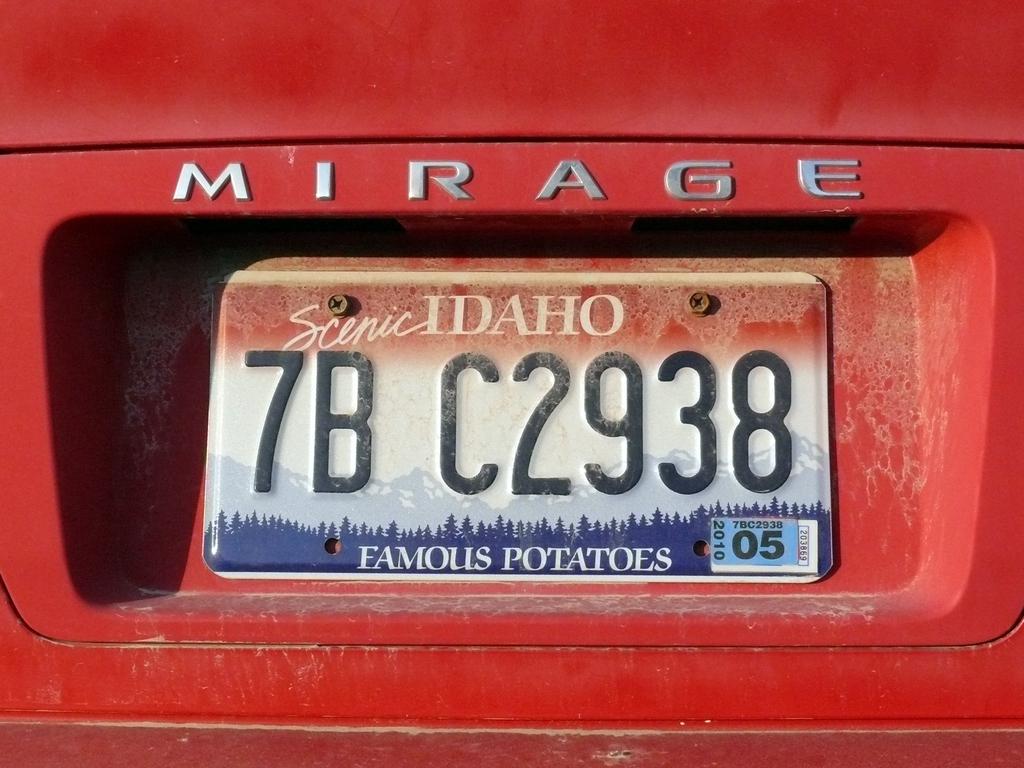What state is the plate from?
Make the answer very short. Idaho. What is this state famous for?
Offer a terse response. Potatoes. 